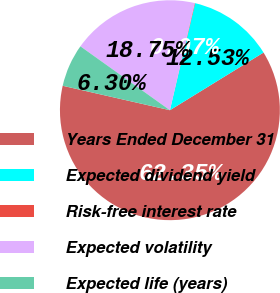Convert chart. <chart><loc_0><loc_0><loc_500><loc_500><pie_chart><fcel>Years Ended December 31<fcel>Expected dividend yield<fcel>Risk-free interest rate<fcel>Expected volatility<fcel>Expected life (years)<nl><fcel>62.35%<fcel>12.53%<fcel>0.07%<fcel>18.75%<fcel>6.3%<nl></chart> 